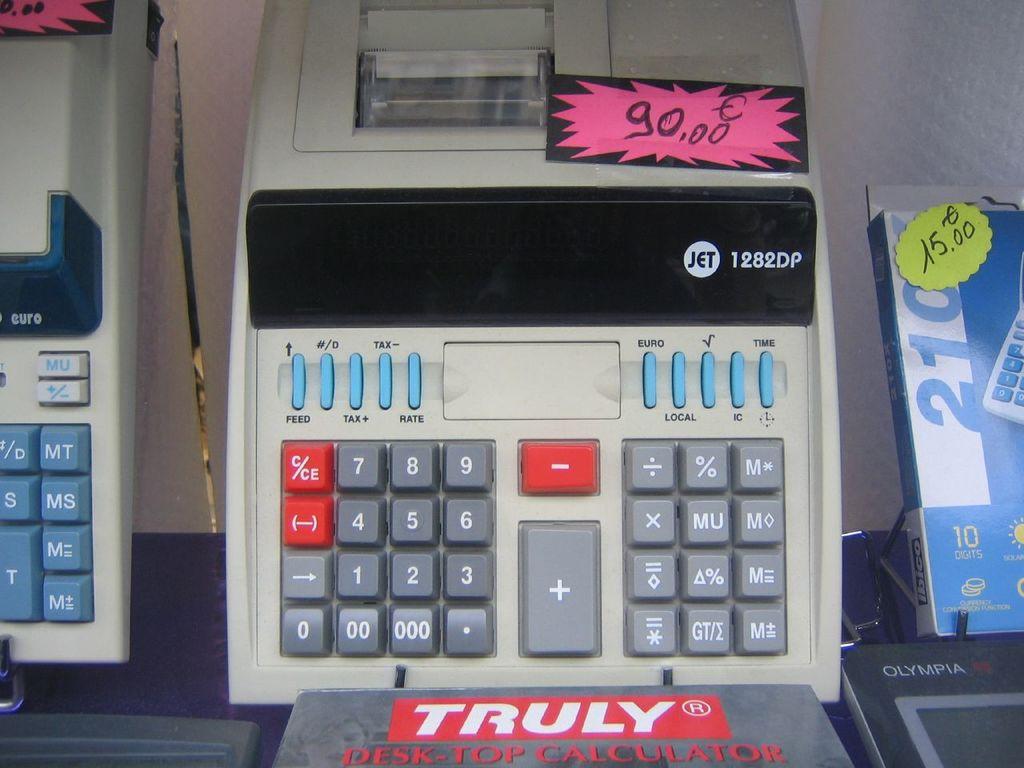What does the white letters in the red box say?
Offer a terse response. Truly. This is tv?
Your response must be concise. No. 